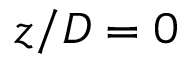Convert formula to latex. <formula><loc_0><loc_0><loc_500><loc_500>z / D = 0</formula> 